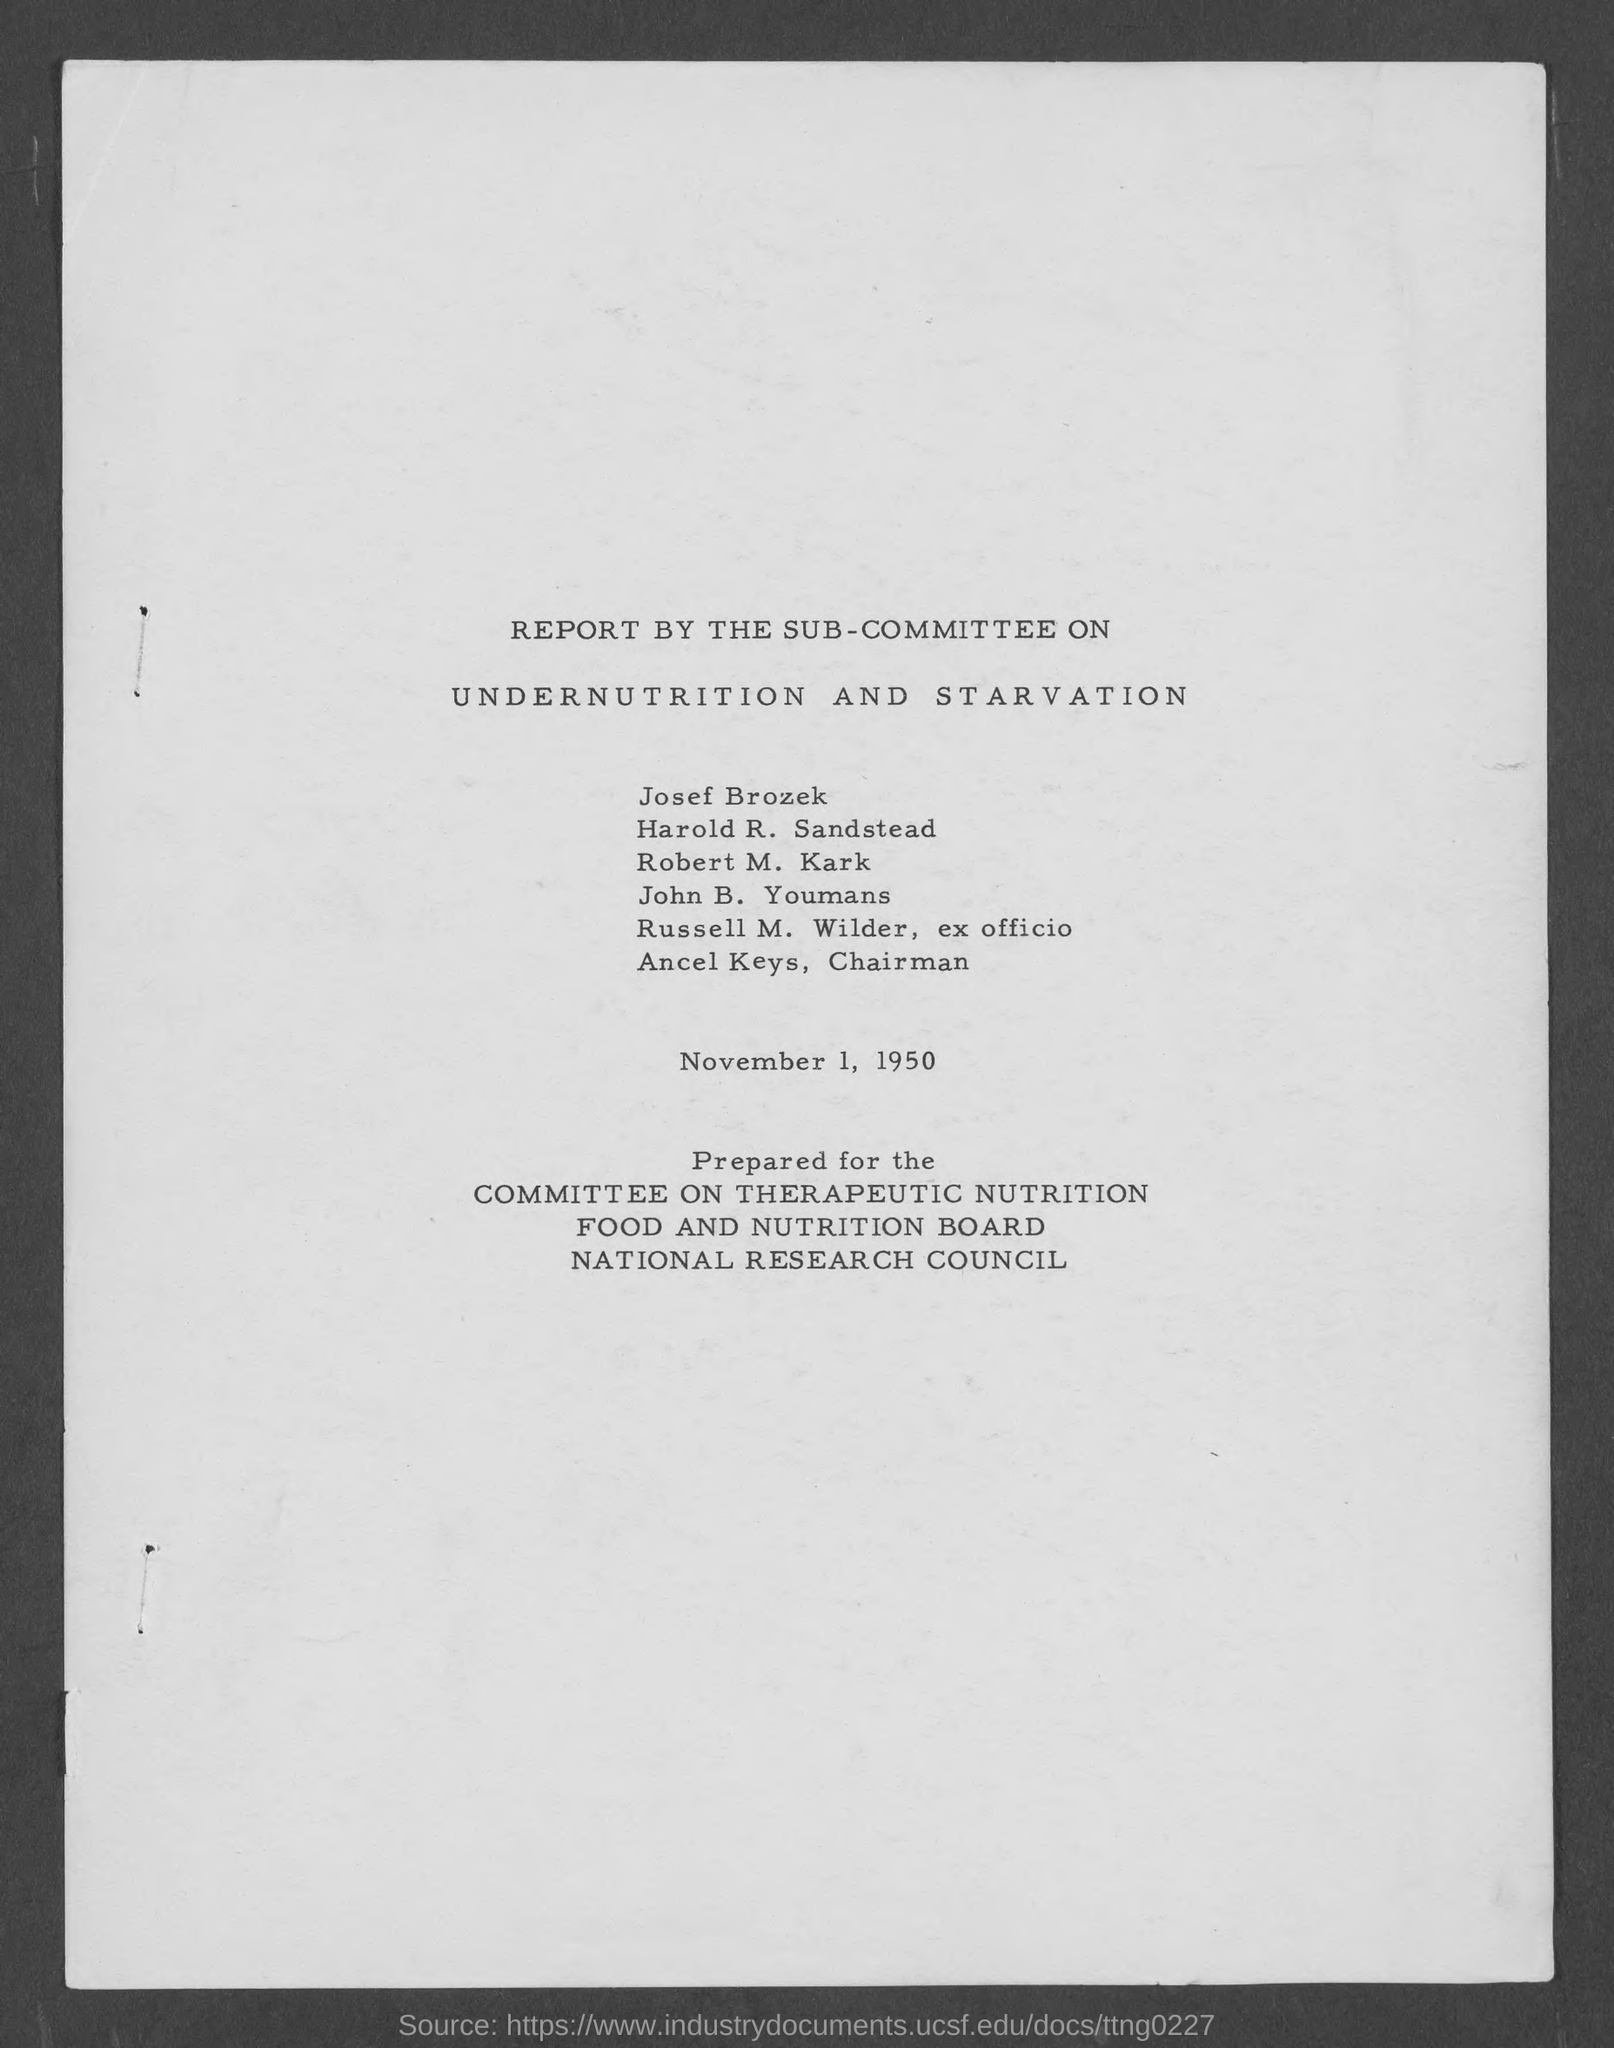Specify some key components in this picture. Russell M. Wilder holds the position of ex officio. The document provides that the date mentioned is November 1, 1950. Ancel Keys served as the chairman of a prominent organization related to nutrition and health. 